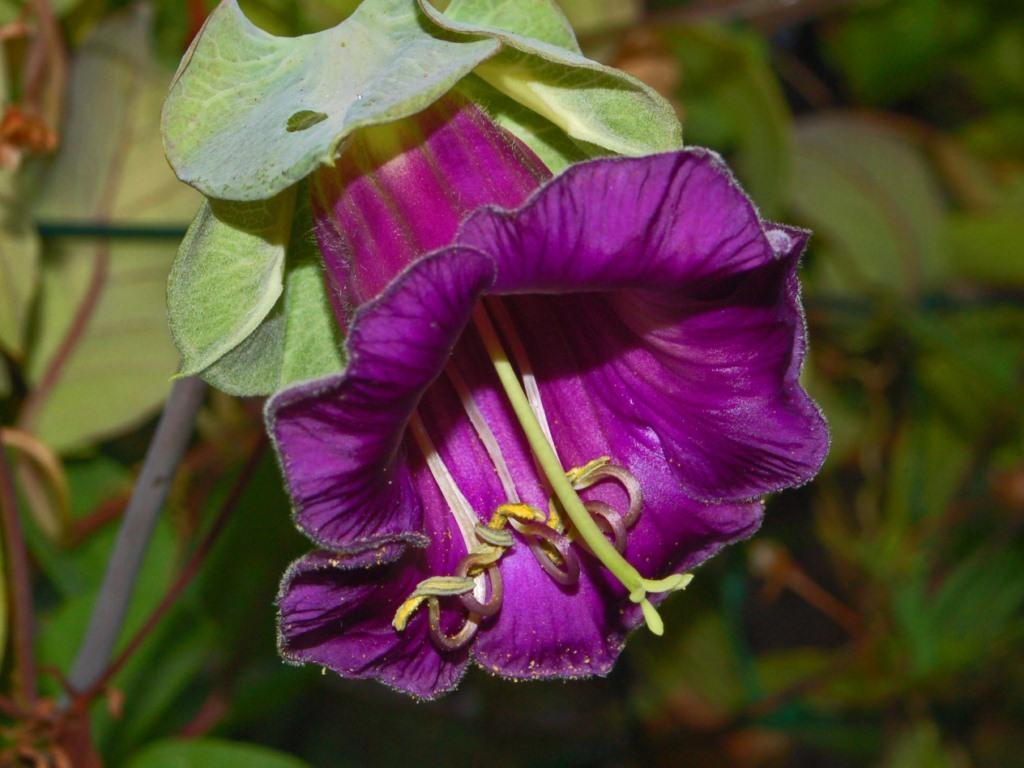How would you summarize this image in a sentence or two? In this picture we can see a flower and green leaves. 